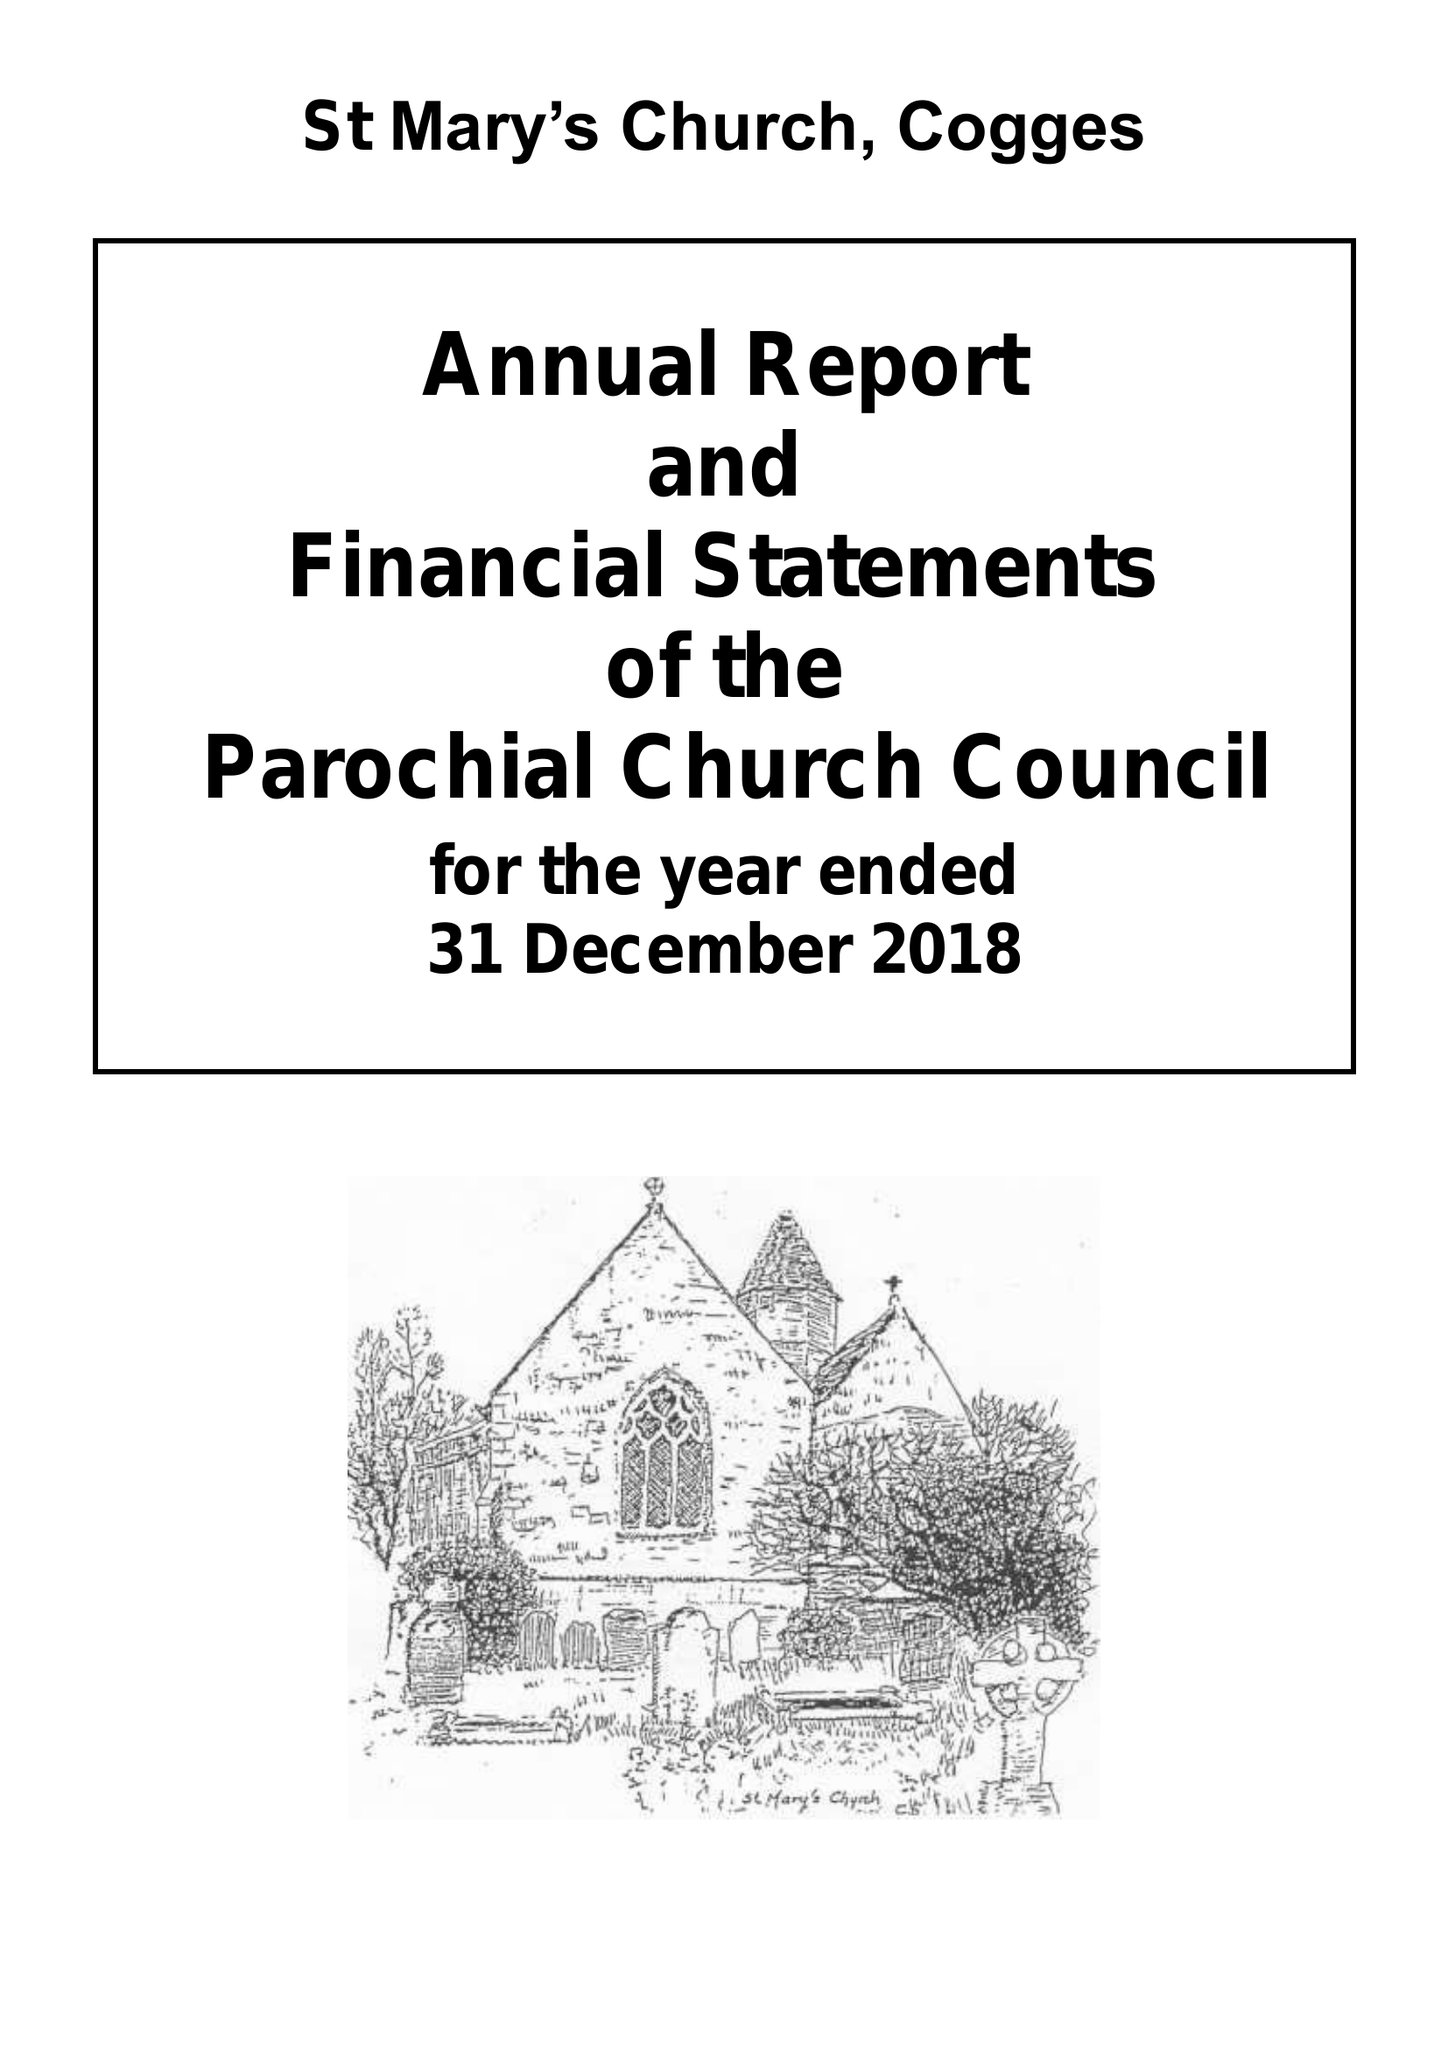What is the value for the report_date?
Answer the question using a single word or phrase. 2018-12-31 